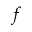Convert formula to latex. <formula><loc_0><loc_0><loc_500><loc_500>f</formula> 